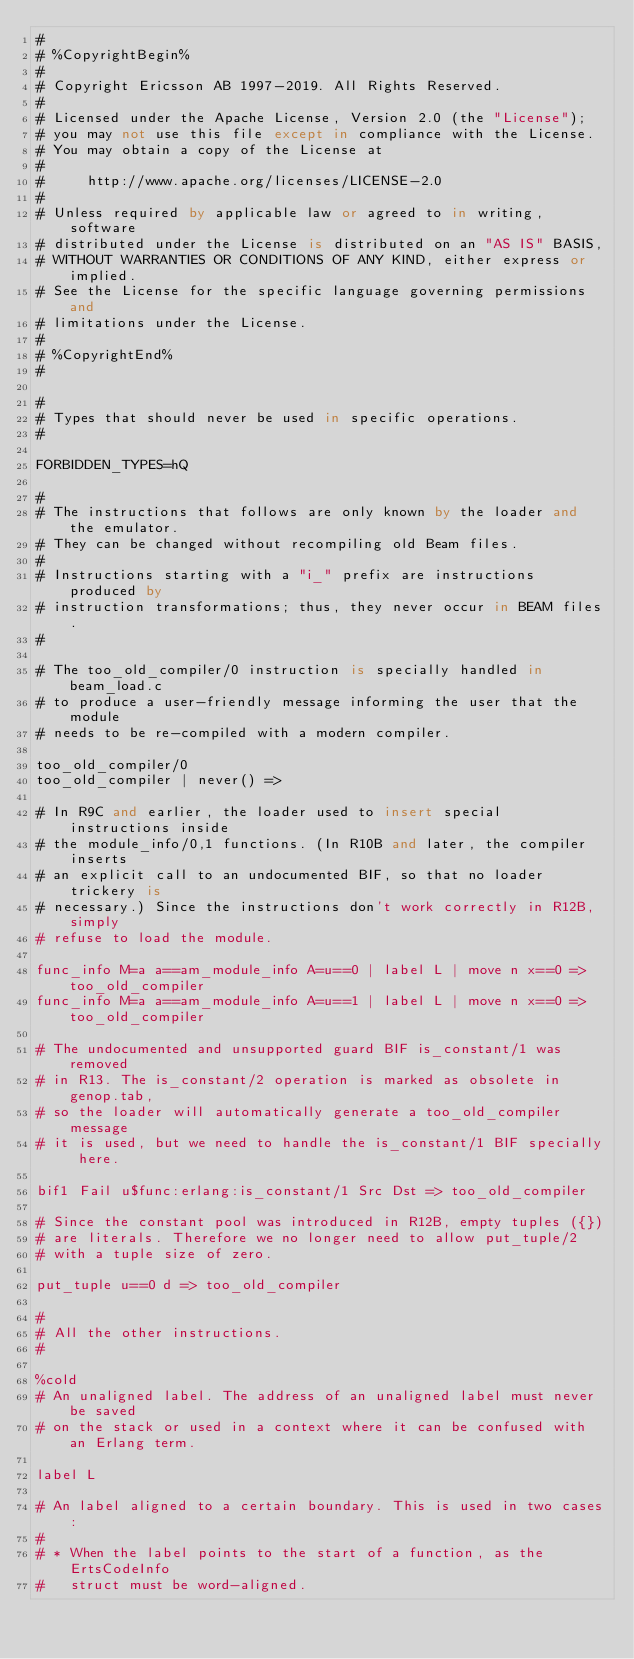<code> <loc_0><loc_0><loc_500><loc_500><_SQL_>#
# %CopyrightBegin%
#
# Copyright Ericsson AB 1997-2019. All Rights Reserved.
#
# Licensed under the Apache License, Version 2.0 (the "License");
# you may not use this file except in compliance with the License.
# You may obtain a copy of the License at
#
#     http://www.apache.org/licenses/LICENSE-2.0
#
# Unless required by applicable law or agreed to in writing, software
# distributed under the License is distributed on an "AS IS" BASIS,
# WITHOUT WARRANTIES OR CONDITIONS OF ANY KIND, either express or implied.
# See the License for the specific language governing permissions and
# limitations under the License.
#
# %CopyrightEnd%
#

#
# Types that should never be used in specific operations.
#

FORBIDDEN_TYPES=hQ

#
# The instructions that follows are only known by the loader and the emulator.
# They can be changed without recompiling old Beam files.
#
# Instructions starting with a "i_" prefix are instructions produced by
# instruction transformations; thus, they never occur in BEAM files.
#

# The too_old_compiler/0 instruction is specially handled in beam_load.c
# to produce a user-friendly message informing the user that the module
# needs to be re-compiled with a modern compiler.

too_old_compiler/0
too_old_compiler | never() =>

# In R9C and earlier, the loader used to insert special instructions inside
# the module_info/0,1 functions. (In R10B and later, the compiler inserts
# an explicit call to an undocumented BIF, so that no loader trickery is
# necessary.) Since the instructions don't work correctly in R12B, simply
# refuse to load the module.

func_info M=a a==am_module_info A=u==0 | label L | move n x==0 => too_old_compiler
func_info M=a a==am_module_info A=u==1 | label L | move n x==0 => too_old_compiler

# The undocumented and unsupported guard BIF is_constant/1 was removed
# in R13. The is_constant/2 operation is marked as obsolete in genop.tab,
# so the loader will automatically generate a too_old_compiler message
# it is used, but we need to handle the is_constant/1 BIF specially here.

bif1 Fail u$func:erlang:is_constant/1 Src Dst => too_old_compiler

# Since the constant pool was introduced in R12B, empty tuples ({})
# are literals. Therefore we no longer need to allow put_tuple/2
# with a tuple size of zero.

put_tuple u==0 d => too_old_compiler

#
# All the other instructions.
#

%cold
# An unaligned label. The address of an unaligned label must never be saved
# on the stack or used in a context where it can be confused with an Erlang term.

label L

# An label aligned to a certain boundary. This is used in two cases:
#
# * When the label points to the start of a function, as the ErtsCodeInfo
#   struct must be word-aligned.</code> 